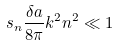<formula> <loc_0><loc_0><loc_500><loc_500>s _ { n } \frac { \delta a } { 8 \pi } k ^ { 2 } n ^ { 2 } \ll 1</formula> 